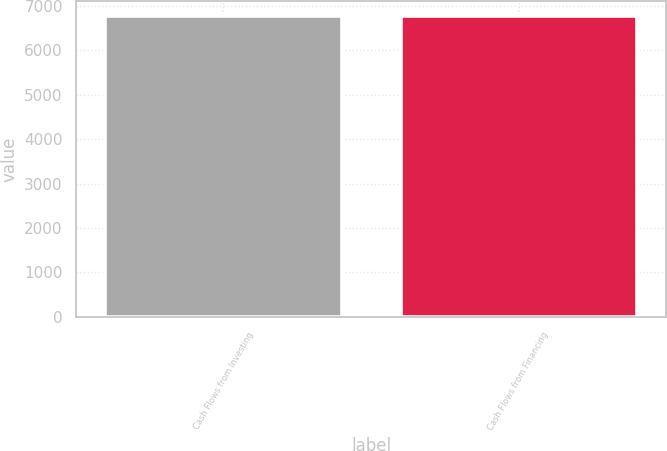Convert chart. <chart><loc_0><loc_0><loc_500><loc_500><bar_chart><fcel>Cash Flows from Investing<fcel>Cash Flows from Financing<nl><fcel>6768<fcel>6768.1<nl></chart> 